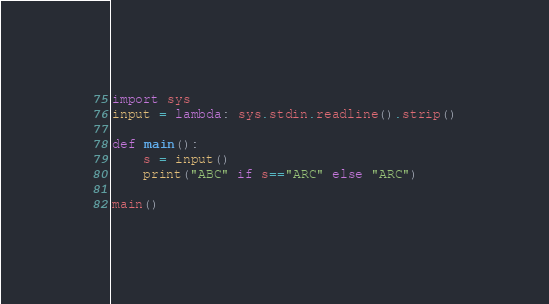Convert code to text. <code><loc_0><loc_0><loc_500><loc_500><_Python_>import sys
input = lambda: sys.stdin.readline().strip()

def main():
    s = input()
    print("ABC" if s=="ARC" else "ARC")

main()
</code> 